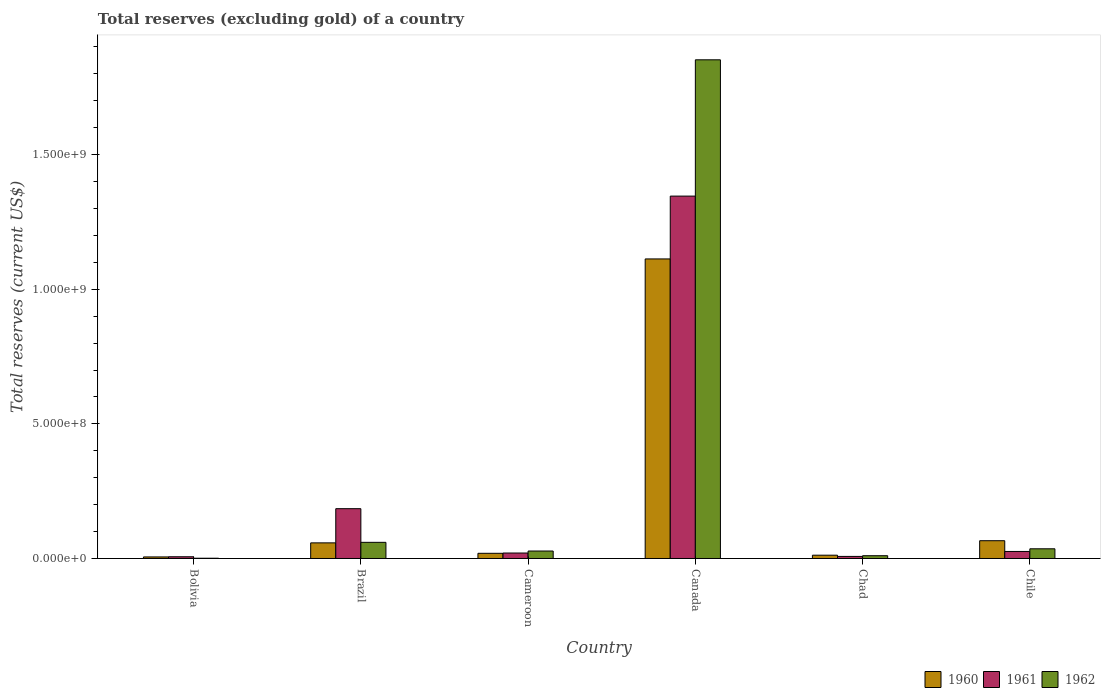How many different coloured bars are there?
Give a very brief answer. 3. Are the number of bars on each tick of the X-axis equal?
Offer a very short reply. Yes. How many bars are there on the 5th tick from the left?
Your answer should be compact. 3. How many bars are there on the 3rd tick from the right?
Make the answer very short. 3. What is the label of the 3rd group of bars from the left?
Ensure brevity in your answer.  Cameroon. In how many cases, is the number of bars for a given country not equal to the number of legend labels?
Provide a short and direct response. 0. What is the total reserves (excluding gold) in 1961 in Cameroon?
Provide a succinct answer. 2.03e+07. Across all countries, what is the maximum total reserves (excluding gold) in 1960?
Offer a terse response. 1.11e+09. What is the total total reserves (excluding gold) in 1961 in the graph?
Keep it short and to the point. 1.59e+09. What is the difference between the total reserves (excluding gold) in 1962 in Chile and the total reserves (excluding gold) in 1960 in Canada?
Offer a very short reply. -1.08e+09. What is the average total reserves (excluding gold) in 1962 per country?
Your answer should be compact. 3.31e+08. What is the difference between the total reserves (excluding gold) of/in 1960 and total reserves (excluding gold) of/in 1961 in Brazil?
Make the answer very short. -1.27e+08. In how many countries, is the total reserves (excluding gold) in 1962 greater than 400000000 US$?
Offer a terse response. 1. What is the ratio of the total reserves (excluding gold) in 1960 in Cameroon to that in Chile?
Offer a very short reply. 0.29. Is the difference between the total reserves (excluding gold) in 1960 in Bolivia and Chile greater than the difference between the total reserves (excluding gold) in 1961 in Bolivia and Chile?
Your response must be concise. No. What is the difference between the highest and the second highest total reserves (excluding gold) in 1961?
Provide a succinct answer. 1.59e+08. What is the difference between the highest and the lowest total reserves (excluding gold) in 1960?
Provide a succinct answer. 1.11e+09. In how many countries, is the total reserves (excluding gold) in 1960 greater than the average total reserves (excluding gold) in 1960 taken over all countries?
Offer a terse response. 1. Is the sum of the total reserves (excluding gold) in 1961 in Cameroon and Chad greater than the maximum total reserves (excluding gold) in 1960 across all countries?
Offer a very short reply. No. What does the 1st bar from the right in Cameroon represents?
Your answer should be compact. 1962. Is it the case that in every country, the sum of the total reserves (excluding gold) in 1961 and total reserves (excluding gold) in 1960 is greater than the total reserves (excluding gold) in 1962?
Offer a very short reply. Yes. How many bars are there?
Ensure brevity in your answer.  18. Are all the bars in the graph horizontal?
Your answer should be very brief. No. How many countries are there in the graph?
Ensure brevity in your answer.  6. What is the difference between two consecutive major ticks on the Y-axis?
Offer a terse response. 5.00e+08. Does the graph contain any zero values?
Make the answer very short. No. Where does the legend appear in the graph?
Your answer should be compact. Bottom right. How many legend labels are there?
Keep it short and to the point. 3. What is the title of the graph?
Make the answer very short. Total reserves (excluding gold) of a country. Does "1967" appear as one of the legend labels in the graph?
Give a very brief answer. No. What is the label or title of the X-axis?
Give a very brief answer. Country. What is the label or title of the Y-axis?
Your answer should be compact. Total reserves (current US$). What is the Total reserves (current US$) of 1960 in Bolivia?
Offer a very short reply. 5.80e+06. What is the Total reserves (current US$) in 1961 in Bolivia?
Offer a terse response. 6.40e+06. What is the Total reserves (current US$) in 1962 in Bolivia?
Give a very brief answer. 1.00e+06. What is the Total reserves (current US$) of 1960 in Brazil?
Provide a short and direct response. 5.80e+07. What is the Total reserves (current US$) of 1961 in Brazil?
Your answer should be very brief. 1.85e+08. What is the Total reserves (current US$) in 1962 in Brazil?
Your response must be concise. 6.00e+07. What is the Total reserves (current US$) in 1960 in Cameroon?
Your answer should be compact. 1.92e+07. What is the Total reserves (current US$) in 1961 in Cameroon?
Your response must be concise. 2.03e+07. What is the Total reserves (current US$) of 1962 in Cameroon?
Offer a terse response. 2.77e+07. What is the Total reserves (current US$) of 1960 in Canada?
Make the answer very short. 1.11e+09. What is the Total reserves (current US$) of 1961 in Canada?
Your answer should be compact. 1.35e+09. What is the Total reserves (current US$) of 1962 in Canada?
Provide a short and direct response. 1.85e+09. What is the Total reserves (current US$) in 1960 in Chad?
Keep it short and to the point. 1.22e+07. What is the Total reserves (current US$) of 1961 in Chad?
Provide a succinct answer. 7.69e+06. What is the Total reserves (current US$) of 1962 in Chad?
Provide a succinct answer. 1.03e+07. What is the Total reserves (current US$) of 1960 in Chile?
Keep it short and to the point. 6.60e+07. What is the Total reserves (current US$) of 1961 in Chile?
Your answer should be compact. 2.61e+07. What is the Total reserves (current US$) of 1962 in Chile?
Provide a short and direct response. 3.60e+07. Across all countries, what is the maximum Total reserves (current US$) of 1960?
Provide a short and direct response. 1.11e+09. Across all countries, what is the maximum Total reserves (current US$) in 1961?
Your answer should be compact. 1.35e+09. Across all countries, what is the maximum Total reserves (current US$) in 1962?
Ensure brevity in your answer.  1.85e+09. Across all countries, what is the minimum Total reserves (current US$) in 1960?
Give a very brief answer. 5.80e+06. Across all countries, what is the minimum Total reserves (current US$) of 1961?
Your answer should be compact. 6.40e+06. Across all countries, what is the minimum Total reserves (current US$) of 1962?
Your answer should be compact. 1.00e+06. What is the total Total reserves (current US$) in 1960 in the graph?
Keep it short and to the point. 1.27e+09. What is the total Total reserves (current US$) of 1961 in the graph?
Provide a succinct answer. 1.59e+09. What is the total Total reserves (current US$) in 1962 in the graph?
Provide a succinct answer. 1.99e+09. What is the difference between the Total reserves (current US$) in 1960 in Bolivia and that in Brazil?
Make the answer very short. -5.22e+07. What is the difference between the Total reserves (current US$) in 1961 in Bolivia and that in Brazil?
Your answer should be very brief. -1.79e+08. What is the difference between the Total reserves (current US$) of 1962 in Bolivia and that in Brazil?
Make the answer very short. -5.90e+07. What is the difference between the Total reserves (current US$) of 1960 in Bolivia and that in Cameroon?
Make the answer very short. -1.34e+07. What is the difference between the Total reserves (current US$) of 1961 in Bolivia and that in Cameroon?
Offer a terse response. -1.39e+07. What is the difference between the Total reserves (current US$) of 1962 in Bolivia and that in Cameroon?
Your answer should be very brief. -2.67e+07. What is the difference between the Total reserves (current US$) in 1960 in Bolivia and that in Canada?
Provide a short and direct response. -1.11e+09. What is the difference between the Total reserves (current US$) in 1961 in Bolivia and that in Canada?
Provide a succinct answer. -1.34e+09. What is the difference between the Total reserves (current US$) of 1962 in Bolivia and that in Canada?
Your answer should be compact. -1.85e+09. What is the difference between the Total reserves (current US$) in 1960 in Bolivia and that in Chad?
Ensure brevity in your answer.  -6.44e+06. What is the difference between the Total reserves (current US$) of 1961 in Bolivia and that in Chad?
Ensure brevity in your answer.  -1.29e+06. What is the difference between the Total reserves (current US$) of 1962 in Bolivia and that in Chad?
Offer a very short reply. -9.30e+06. What is the difference between the Total reserves (current US$) of 1960 in Bolivia and that in Chile?
Your answer should be compact. -6.02e+07. What is the difference between the Total reserves (current US$) in 1961 in Bolivia and that in Chile?
Give a very brief answer. -1.97e+07. What is the difference between the Total reserves (current US$) of 1962 in Bolivia and that in Chile?
Your response must be concise. -3.50e+07. What is the difference between the Total reserves (current US$) of 1960 in Brazil and that in Cameroon?
Make the answer very short. 3.88e+07. What is the difference between the Total reserves (current US$) of 1961 in Brazil and that in Cameroon?
Ensure brevity in your answer.  1.65e+08. What is the difference between the Total reserves (current US$) of 1962 in Brazil and that in Cameroon?
Offer a terse response. 3.23e+07. What is the difference between the Total reserves (current US$) in 1960 in Brazil and that in Canada?
Provide a succinct answer. -1.05e+09. What is the difference between the Total reserves (current US$) in 1961 in Brazil and that in Canada?
Your response must be concise. -1.16e+09. What is the difference between the Total reserves (current US$) of 1962 in Brazil and that in Canada?
Ensure brevity in your answer.  -1.79e+09. What is the difference between the Total reserves (current US$) in 1960 in Brazil and that in Chad?
Ensure brevity in your answer.  4.58e+07. What is the difference between the Total reserves (current US$) in 1961 in Brazil and that in Chad?
Offer a terse response. 1.77e+08. What is the difference between the Total reserves (current US$) of 1962 in Brazil and that in Chad?
Provide a short and direct response. 4.97e+07. What is the difference between the Total reserves (current US$) in 1960 in Brazil and that in Chile?
Keep it short and to the point. -8.00e+06. What is the difference between the Total reserves (current US$) of 1961 in Brazil and that in Chile?
Offer a terse response. 1.59e+08. What is the difference between the Total reserves (current US$) in 1962 in Brazil and that in Chile?
Provide a succinct answer. 2.40e+07. What is the difference between the Total reserves (current US$) of 1960 in Cameroon and that in Canada?
Ensure brevity in your answer.  -1.09e+09. What is the difference between the Total reserves (current US$) in 1961 in Cameroon and that in Canada?
Ensure brevity in your answer.  -1.33e+09. What is the difference between the Total reserves (current US$) in 1962 in Cameroon and that in Canada?
Offer a terse response. -1.82e+09. What is the difference between the Total reserves (current US$) of 1961 in Cameroon and that in Chad?
Your answer should be compact. 1.26e+07. What is the difference between the Total reserves (current US$) of 1962 in Cameroon and that in Chad?
Your answer should be very brief. 1.74e+07. What is the difference between the Total reserves (current US$) of 1960 in Cameroon and that in Chile?
Your answer should be compact. -4.68e+07. What is the difference between the Total reserves (current US$) of 1961 in Cameroon and that in Chile?
Your answer should be very brief. -5.80e+06. What is the difference between the Total reserves (current US$) of 1962 in Cameroon and that in Chile?
Your answer should be compact. -8.29e+06. What is the difference between the Total reserves (current US$) in 1960 in Canada and that in Chad?
Your response must be concise. 1.10e+09. What is the difference between the Total reserves (current US$) in 1961 in Canada and that in Chad?
Offer a very short reply. 1.34e+09. What is the difference between the Total reserves (current US$) in 1962 in Canada and that in Chad?
Offer a terse response. 1.84e+09. What is the difference between the Total reserves (current US$) of 1960 in Canada and that in Chile?
Offer a very short reply. 1.05e+09. What is the difference between the Total reserves (current US$) in 1961 in Canada and that in Chile?
Provide a short and direct response. 1.32e+09. What is the difference between the Total reserves (current US$) in 1962 in Canada and that in Chile?
Keep it short and to the point. 1.82e+09. What is the difference between the Total reserves (current US$) in 1960 in Chad and that in Chile?
Ensure brevity in your answer.  -5.38e+07. What is the difference between the Total reserves (current US$) of 1961 in Chad and that in Chile?
Your answer should be very brief. -1.84e+07. What is the difference between the Total reserves (current US$) in 1962 in Chad and that in Chile?
Your answer should be very brief. -2.57e+07. What is the difference between the Total reserves (current US$) in 1960 in Bolivia and the Total reserves (current US$) in 1961 in Brazil?
Make the answer very short. -1.79e+08. What is the difference between the Total reserves (current US$) in 1960 in Bolivia and the Total reserves (current US$) in 1962 in Brazil?
Your response must be concise. -5.42e+07. What is the difference between the Total reserves (current US$) of 1961 in Bolivia and the Total reserves (current US$) of 1962 in Brazil?
Provide a succinct answer. -5.36e+07. What is the difference between the Total reserves (current US$) in 1960 in Bolivia and the Total reserves (current US$) in 1961 in Cameroon?
Provide a succinct answer. -1.45e+07. What is the difference between the Total reserves (current US$) of 1960 in Bolivia and the Total reserves (current US$) of 1962 in Cameroon?
Offer a terse response. -2.19e+07. What is the difference between the Total reserves (current US$) in 1961 in Bolivia and the Total reserves (current US$) in 1962 in Cameroon?
Ensure brevity in your answer.  -2.13e+07. What is the difference between the Total reserves (current US$) of 1960 in Bolivia and the Total reserves (current US$) of 1961 in Canada?
Provide a short and direct response. -1.34e+09. What is the difference between the Total reserves (current US$) in 1960 in Bolivia and the Total reserves (current US$) in 1962 in Canada?
Provide a short and direct response. -1.85e+09. What is the difference between the Total reserves (current US$) of 1961 in Bolivia and the Total reserves (current US$) of 1962 in Canada?
Provide a short and direct response. -1.85e+09. What is the difference between the Total reserves (current US$) in 1960 in Bolivia and the Total reserves (current US$) in 1961 in Chad?
Provide a succinct answer. -1.89e+06. What is the difference between the Total reserves (current US$) in 1960 in Bolivia and the Total reserves (current US$) in 1962 in Chad?
Offer a very short reply. -4.50e+06. What is the difference between the Total reserves (current US$) in 1961 in Bolivia and the Total reserves (current US$) in 1962 in Chad?
Provide a short and direct response. -3.90e+06. What is the difference between the Total reserves (current US$) in 1960 in Bolivia and the Total reserves (current US$) in 1961 in Chile?
Give a very brief answer. -2.03e+07. What is the difference between the Total reserves (current US$) in 1960 in Bolivia and the Total reserves (current US$) in 1962 in Chile?
Your response must be concise. -3.02e+07. What is the difference between the Total reserves (current US$) of 1961 in Bolivia and the Total reserves (current US$) of 1962 in Chile?
Give a very brief answer. -2.96e+07. What is the difference between the Total reserves (current US$) of 1960 in Brazil and the Total reserves (current US$) of 1961 in Cameroon?
Offer a terse response. 3.77e+07. What is the difference between the Total reserves (current US$) in 1960 in Brazil and the Total reserves (current US$) in 1962 in Cameroon?
Provide a short and direct response. 3.03e+07. What is the difference between the Total reserves (current US$) of 1961 in Brazil and the Total reserves (current US$) of 1962 in Cameroon?
Your answer should be compact. 1.57e+08. What is the difference between the Total reserves (current US$) of 1960 in Brazil and the Total reserves (current US$) of 1961 in Canada?
Ensure brevity in your answer.  -1.29e+09. What is the difference between the Total reserves (current US$) in 1960 in Brazil and the Total reserves (current US$) in 1962 in Canada?
Give a very brief answer. -1.79e+09. What is the difference between the Total reserves (current US$) of 1961 in Brazil and the Total reserves (current US$) of 1962 in Canada?
Your answer should be very brief. -1.67e+09. What is the difference between the Total reserves (current US$) in 1960 in Brazil and the Total reserves (current US$) in 1961 in Chad?
Make the answer very short. 5.03e+07. What is the difference between the Total reserves (current US$) of 1960 in Brazil and the Total reserves (current US$) of 1962 in Chad?
Provide a succinct answer. 4.77e+07. What is the difference between the Total reserves (current US$) of 1961 in Brazil and the Total reserves (current US$) of 1962 in Chad?
Your answer should be compact. 1.75e+08. What is the difference between the Total reserves (current US$) in 1960 in Brazil and the Total reserves (current US$) in 1961 in Chile?
Provide a succinct answer. 3.19e+07. What is the difference between the Total reserves (current US$) of 1960 in Brazil and the Total reserves (current US$) of 1962 in Chile?
Keep it short and to the point. 2.20e+07. What is the difference between the Total reserves (current US$) of 1961 in Brazil and the Total reserves (current US$) of 1962 in Chile?
Your answer should be very brief. 1.49e+08. What is the difference between the Total reserves (current US$) of 1960 in Cameroon and the Total reserves (current US$) of 1961 in Canada?
Your response must be concise. -1.33e+09. What is the difference between the Total reserves (current US$) in 1960 in Cameroon and the Total reserves (current US$) in 1962 in Canada?
Ensure brevity in your answer.  -1.83e+09. What is the difference between the Total reserves (current US$) in 1961 in Cameroon and the Total reserves (current US$) in 1962 in Canada?
Give a very brief answer. -1.83e+09. What is the difference between the Total reserves (current US$) in 1960 in Cameroon and the Total reserves (current US$) in 1961 in Chad?
Provide a succinct answer. 1.16e+07. What is the difference between the Total reserves (current US$) of 1960 in Cameroon and the Total reserves (current US$) of 1962 in Chad?
Your response must be concise. 8.94e+06. What is the difference between the Total reserves (current US$) in 1961 in Cameroon and the Total reserves (current US$) in 1962 in Chad?
Your answer should be very brief. 1.00e+07. What is the difference between the Total reserves (current US$) in 1960 in Cameroon and the Total reserves (current US$) in 1961 in Chile?
Your response must be concise. -6.86e+06. What is the difference between the Total reserves (current US$) of 1960 in Cameroon and the Total reserves (current US$) of 1962 in Chile?
Your answer should be very brief. -1.68e+07. What is the difference between the Total reserves (current US$) in 1961 in Cameroon and the Total reserves (current US$) in 1962 in Chile?
Offer a terse response. -1.57e+07. What is the difference between the Total reserves (current US$) of 1960 in Canada and the Total reserves (current US$) of 1961 in Chad?
Provide a succinct answer. 1.10e+09. What is the difference between the Total reserves (current US$) in 1960 in Canada and the Total reserves (current US$) in 1962 in Chad?
Keep it short and to the point. 1.10e+09. What is the difference between the Total reserves (current US$) of 1961 in Canada and the Total reserves (current US$) of 1962 in Chad?
Provide a succinct answer. 1.34e+09. What is the difference between the Total reserves (current US$) of 1960 in Canada and the Total reserves (current US$) of 1961 in Chile?
Offer a terse response. 1.09e+09. What is the difference between the Total reserves (current US$) in 1960 in Canada and the Total reserves (current US$) in 1962 in Chile?
Your answer should be very brief. 1.08e+09. What is the difference between the Total reserves (current US$) of 1961 in Canada and the Total reserves (current US$) of 1962 in Chile?
Offer a very short reply. 1.31e+09. What is the difference between the Total reserves (current US$) in 1960 in Chad and the Total reserves (current US$) in 1961 in Chile?
Keep it short and to the point. -1.39e+07. What is the difference between the Total reserves (current US$) of 1960 in Chad and the Total reserves (current US$) of 1962 in Chile?
Keep it short and to the point. -2.38e+07. What is the difference between the Total reserves (current US$) of 1961 in Chad and the Total reserves (current US$) of 1962 in Chile?
Your answer should be very brief. -2.83e+07. What is the average Total reserves (current US$) in 1960 per country?
Make the answer very short. 2.12e+08. What is the average Total reserves (current US$) in 1961 per country?
Provide a succinct answer. 2.65e+08. What is the average Total reserves (current US$) of 1962 per country?
Provide a short and direct response. 3.31e+08. What is the difference between the Total reserves (current US$) of 1960 and Total reserves (current US$) of 1961 in Bolivia?
Offer a terse response. -6.00e+05. What is the difference between the Total reserves (current US$) of 1960 and Total reserves (current US$) of 1962 in Bolivia?
Make the answer very short. 4.80e+06. What is the difference between the Total reserves (current US$) in 1961 and Total reserves (current US$) in 1962 in Bolivia?
Your answer should be compact. 5.40e+06. What is the difference between the Total reserves (current US$) in 1960 and Total reserves (current US$) in 1961 in Brazil?
Offer a terse response. -1.27e+08. What is the difference between the Total reserves (current US$) of 1961 and Total reserves (current US$) of 1962 in Brazil?
Provide a short and direct response. 1.25e+08. What is the difference between the Total reserves (current US$) in 1960 and Total reserves (current US$) in 1961 in Cameroon?
Your response must be concise. -1.06e+06. What is the difference between the Total reserves (current US$) in 1960 and Total reserves (current US$) in 1962 in Cameroon?
Offer a terse response. -8.47e+06. What is the difference between the Total reserves (current US$) of 1961 and Total reserves (current US$) of 1962 in Cameroon?
Give a very brief answer. -7.41e+06. What is the difference between the Total reserves (current US$) in 1960 and Total reserves (current US$) in 1961 in Canada?
Your response must be concise. -2.33e+08. What is the difference between the Total reserves (current US$) of 1960 and Total reserves (current US$) of 1962 in Canada?
Offer a very short reply. -7.39e+08. What is the difference between the Total reserves (current US$) in 1961 and Total reserves (current US$) in 1962 in Canada?
Ensure brevity in your answer.  -5.06e+08. What is the difference between the Total reserves (current US$) of 1960 and Total reserves (current US$) of 1961 in Chad?
Ensure brevity in your answer.  4.55e+06. What is the difference between the Total reserves (current US$) of 1960 and Total reserves (current US$) of 1962 in Chad?
Make the answer very short. 1.94e+06. What is the difference between the Total reserves (current US$) in 1961 and Total reserves (current US$) in 1962 in Chad?
Provide a short and direct response. -2.61e+06. What is the difference between the Total reserves (current US$) in 1960 and Total reserves (current US$) in 1961 in Chile?
Keep it short and to the point. 3.99e+07. What is the difference between the Total reserves (current US$) in 1960 and Total reserves (current US$) in 1962 in Chile?
Your answer should be compact. 3.00e+07. What is the difference between the Total reserves (current US$) in 1961 and Total reserves (current US$) in 1962 in Chile?
Provide a succinct answer. -9.90e+06. What is the ratio of the Total reserves (current US$) in 1961 in Bolivia to that in Brazil?
Make the answer very short. 0.03. What is the ratio of the Total reserves (current US$) of 1962 in Bolivia to that in Brazil?
Ensure brevity in your answer.  0.02. What is the ratio of the Total reserves (current US$) in 1960 in Bolivia to that in Cameroon?
Keep it short and to the point. 0.3. What is the ratio of the Total reserves (current US$) in 1961 in Bolivia to that in Cameroon?
Ensure brevity in your answer.  0.32. What is the ratio of the Total reserves (current US$) in 1962 in Bolivia to that in Cameroon?
Your answer should be compact. 0.04. What is the ratio of the Total reserves (current US$) in 1960 in Bolivia to that in Canada?
Keep it short and to the point. 0.01. What is the ratio of the Total reserves (current US$) in 1961 in Bolivia to that in Canada?
Offer a very short reply. 0. What is the ratio of the Total reserves (current US$) of 1960 in Bolivia to that in Chad?
Your answer should be very brief. 0.47. What is the ratio of the Total reserves (current US$) of 1961 in Bolivia to that in Chad?
Your response must be concise. 0.83. What is the ratio of the Total reserves (current US$) of 1962 in Bolivia to that in Chad?
Give a very brief answer. 0.1. What is the ratio of the Total reserves (current US$) of 1960 in Bolivia to that in Chile?
Make the answer very short. 0.09. What is the ratio of the Total reserves (current US$) in 1961 in Bolivia to that in Chile?
Give a very brief answer. 0.25. What is the ratio of the Total reserves (current US$) of 1962 in Bolivia to that in Chile?
Offer a very short reply. 0.03. What is the ratio of the Total reserves (current US$) of 1960 in Brazil to that in Cameroon?
Provide a succinct answer. 3.01. What is the ratio of the Total reserves (current US$) of 1961 in Brazil to that in Cameroon?
Offer a terse response. 9.11. What is the ratio of the Total reserves (current US$) of 1962 in Brazil to that in Cameroon?
Your answer should be very brief. 2.17. What is the ratio of the Total reserves (current US$) of 1960 in Brazil to that in Canada?
Keep it short and to the point. 0.05. What is the ratio of the Total reserves (current US$) in 1961 in Brazil to that in Canada?
Your response must be concise. 0.14. What is the ratio of the Total reserves (current US$) of 1962 in Brazil to that in Canada?
Keep it short and to the point. 0.03. What is the ratio of the Total reserves (current US$) of 1960 in Brazil to that in Chad?
Keep it short and to the point. 4.74. What is the ratio of the Total reserves (current US$) in 1961 in Brazil to that in Chad?
Your answer should be compact. 24.06. What is the ratio of the Total reserves (current US$) of 1962 in Brazil to that in Chad?
Make the answer very short. 5.83. What is the ratio of the Total reserves (current US$) of 1960 in Brazil to that in Chile?
Your answer should be compact. 0.88. What is the ratio of the Total reserves (current US$) in 1961 in Brazil to that in Chile?
Your answer should be compact. 7.09. What is the ratio of the Total reserves (current US$) in 1962 in Brazil to that in Chile?
Offer a terse response. 1.67. What is the ratio of the Total reserves (current US$) in 1960 in Cameroon to that in Canada?
Offer a very short reply. 0.02. What is the ratio of the Total reserves (current US$) of 1961 in Cameroon to that in Canada?
Ensure brevity in your answer.  0.02. What is the ratio of the Total reserves (current US$) in 1962 in Cameroon to that in Canada?
Your response must be concise. 0.01. What is the ratio of the Total reserves (current US$) of 1960 in Cameroon to that in Chad?
Your answer should be compact. 1.57. What is the ratio of the Total reserves (current US$) in 1961 in Cameroon to that in Chad?
Your response must be concise. 2.64. What is the ratio of the Total reserves (current US$) of 1962 in Cameroon to that in Chad?
Offer a terse response. 2.69. What is the ratio of the Total reserves (current US$) in 1960 in Cameroon to that in Chile?
Make the answer very short. 0.29. What is the ratio of the Total reserves (current US$) in 1962 in Cameroon to that in Chile?
Your answer should be compact. 0.77. What is the ratio of the Total reserves (current US$) of 1960 in Canada to that in Chad?
Provide a short and direct response. 90.89. What is the ratio of the Total reserves (current US$) of 1961 in Canada to that in Chad?
Keep it short and to the point. 175.01. What is the ratio of the Total reserves (current US$) in 1962 in Canada to that in Chad?
Provide a succinct answer. 179.81. What is the ratio of the Total reserves (current US$) of 1960 in Canada to that in Chile?
Provide a short and direct response. 16.86. What is the ratio of the Total reserves (current US$) of 1961 in Canada to that in Chile?
Make the answer very short. 51.56. What is the ratio of the Total reserves (current US$) of 1962 in Canada to that in Chile?
Your response must be concise. 51.44. What is the ratio of the Total reserves (current US$) in 1960 in Chad to that in Chile?
Give a very brief answer. 0.19. What is the ratio of the Total reserves (current US$) in 1961 in Chad to that in Chile?
Ensure brevity in your answer.  0.29. What is the ratio of the Total reserves (current US$) of 1962 in Chad to that in Chile?
Your response must be concise. 0.29. What is the difference between the highest and the second highest Total reserves (current US$) in 1960?
Make the answer very short. 1.05e+09. What is the difference between the highest and the second highest Total reserves (current US$) in 1961?
Provide a short and direct response. 1.16e+09. What is the difference between the highest and the second highest Total reserves (current US$) of 1962?
Offer a very short reply. 1.79e+09. What is the difference between the highest and the lowest Total reserves (current US$) in 1960?
Keep it short and to the point. 1.11e+09. What is the difference between the highest and the lowest Total reserves (current US$) of 1961?
Make the answer very short. 1.34e+09. What is the difference between the highest and the lowest Total reserves (current US$) in 1962?
Your response must be concise. 1.85e+09. 